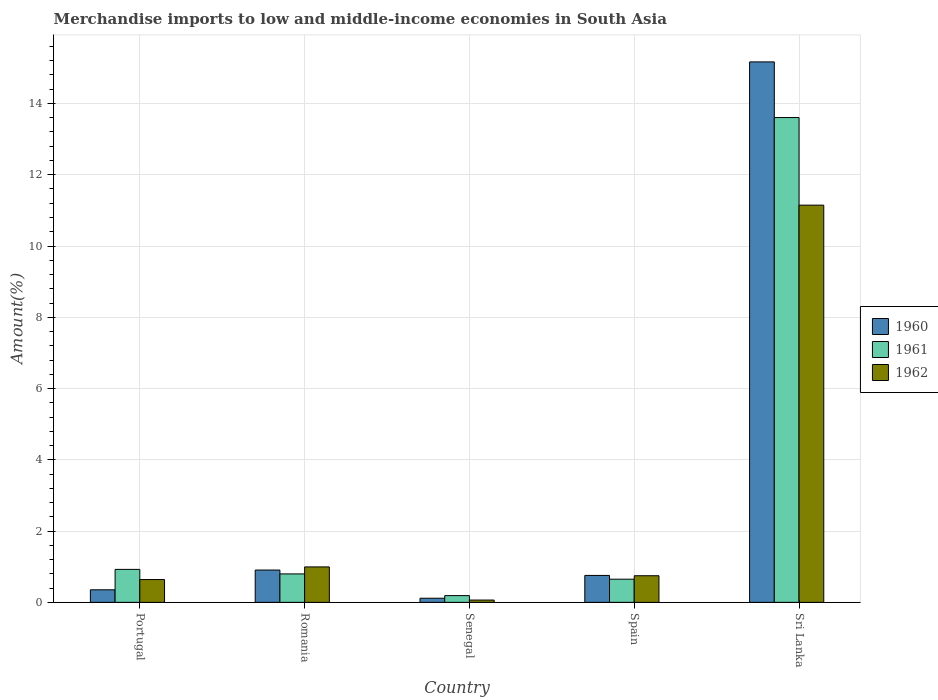How many different coloured bars are there?
Make the answer very short. 3. How many groups of bars are there?
Your response must be concise. 5. Are the number of bars on each tick of the X-axis equal?
Keep it short and to the point. Yes. How many bars are there on the 5th tick from the right?
Give a very brief answer. 3. What is the label of the 3rd group of bars from the left?
Provide a short and direct response. Senegal. What is the percentage of amount earned from merchandise imports in 1960 in Romania?
Offer a very short reply. 0.91. Across all countries, what is the maximum percentage of amount earned from merchandise imports in 1960?
Your answer should be very brief. 15.17. Across all countries, what is the minimum percentage of amount earned from merchandise imports in 1962?
Provide a succinct answer. 0.06. In which country was the percentage of amount earned from merchandise imports in 1961 maximum?
Offer a terse response. Sri Lanka. In which country was the percentage of amount earned from merchandise imports in 1962 minimum?
Ensure brevity in your answer.  Senegal. What is the total percentage of amount earned from merchandise imports in 1960 in the graph?
Your answer should be very brief. 17.3. What is the difference between the percentage of amount earned from merchandise imports in 1960 in Portugal and that in Senegal?
Provide a short and direct response. 0.24. What is the difference between the percentage of amount earned from merchandise imports in 1961 in Sri Lanka and the percentage of amount earned from merchandise imports in 1962 in Senegal?
Your answer should be compact. 13.54. What is the average percentage of amount earned from merchandise imports in 1961 per country?
Your answer should be very brief. 3.23. What is the difference between the percentage of amount earned from merchandise imports of/in 1961 and percentage of amount earned from merchandise imports of/in 1962 in Sri Lanka?
Offer a very short reply. 2.46. In how many countries, is the percentage of amount earned from merchandise imports in 1962 greater than 4.4 %?
Your response must be concise. 1. What is the ratio of the percentage of amount earned from merchandise imports in 1962 in Portugal to that in Sri Lanka?
Your response must be concise. 0.06. Is the percentage of amount earned from merchandise imports in 1961 in Romania less than that in Sri Lanka?
Offer a terse response. Yes. What is the difference between the highest and the second highest percentage of amount earned from merchandise imports in 1962?
Provide a short and direct response. 0.25. What is the difference between the highest and the lowest percentage of amount earned from merchandise imports in 1962?
Provide a succinct answer. 11.08. How many bars are there?
Offer a terse response. 15. Are all the bars in the graph horizontal?
Your answer should be compact. No. How many countries are there in the graph?
Provide a succinct answer. 5. What is the difference between two consecutive major ticks on the Y-axis?
Keep it short and to the point. 2. Where does the legend appear in the graph?
Provide a short and direct response. Center right. How are the legend labels stacked?
Provide a succinct answer. Vertical. What is the title of the graph?
Give a very brief answer. Merchandise imports to low and middle-income economies in South Asia. Does "2003" appear as one of the legend labels in the graph?
Your answer should be very brief. No. What is the label or title of the X-axis?
Offer a very short reply. Country. What is the label or title of the Y-axis?
Make the answer very short. Amount(%). What is the Amount(%) of 1960 in Portugal?
Your response must be concise. 0.35. What is the Amount(%) in 1961 in Portugal?
Offer a very short reply. 0.93. What is the Amount(%) of 1962 in Portugal?
Offer a terse response. 0.64. What is the Amount(%) in 1960 in Romania?
Offer a very short reply. 0.91. What is the Amount(%) in 1961 in Romania?
Provide a short and direct response. 0.8. What is the Amount(%) of 1962 in Romania?
Give a very brief answer. 0.99. What is the Amount(%) of 1960 in Senegal?
Offer a very short reply. 0.12. What is the Amount(%) in 1961 in Senegal?
Your answer should be compact. 0.19. What is the Amount(%) of 1962 in Senegal?
Your answer should be compact. 0.06. What is the Amount(%) of 1960 in Spain?
Your answer should be very brief. 0.76. What is the Amount(%) of 1961 in Spain?
Ensure brevity in your answer.  0.65. What is the Amount(%) of 1962 in Spain?
Provide a short and direct response. 0.75. What is the Amount(%) of 1960 in Sri Lanka?
Offer a very short reply. 15.17. What is the Amount(%) of 1961 in Sri Lanka?
Provide a short and direct response. 13.6. What is the Amount(%) in 1962 in Sri Lanka?
Provide a short and direct response. 11.15. Across all countries, what is the maximum Amount(%) in 1960?
Provide a succinct answer. 15.17. Across all countries, what is the maximum Amount(%) of 1961?
Make the answer very short. 13.6. Across all countries, what is the maximum Amount(%) of 1962?
Make the answer very short. 11.15. Across all countries, what is the minimum Amount(%) in 1960?
Offer a terse response. 0.12. Across all countries, what is the minimum Amount(%) of 1961?
Keep it short and to the point. 0.19. Across all countries, what is the minimum Amount(%) of 1962?
Your answer should be very brief. 0.06. What is the total Amount(%) in 1960 in the graph?
Your response must be concise. 17.3. What is the total Amount(%) in 1961 in the graph?
Give a very brief answer. 16.17. What is the total Amount(%) in 1962 in the graph?
Your answer should be very brief. 13.59. What is the difference between the Amount(%) in 1960 in Portugal and that in Romania?
Make the answer very short. -0.55. What is the difference between the Amount(%) of 1961 in Portugal and that in Romania?
Your answer should be very brief. 0.13. What is the difference between the Amount(%) of 1962 in Portugal and that in Romania?
Offer a very short reply. -0.35. What is the difference between the Amount(%) in 1960 in Portugal and that in Senegal?
Your response must be concise. 0.24. What is the difference between the Amount(%) in 1961 in Portugal and that in Senegal?
Give a very brief answer. 0.74. What is the difference between the Amount(%) of 1962 in Portugal and that in Senegal?
Give a very brief answer. 0.57. What is the difference between the Amount(%) in 1960 in Portugal and that in Spain?
Make the answer very short. -0.4. What is the difference between the Amount(%) in 1961 in Portugal and that in Spain?
Your answer should be compact. 0.28. What is the difference between the Amount(%) of 1962 in Portugal and that in Spain?
Your answer should be compact. -0.11. What is the difference between the Amount(%) in 1960 in Portugal and that in Sri Lanka?
Your response must be concise. -14.81. What is the difference between the Amount(%) in 1961 in Portugal and that in Sri Lanka?
Your answer should be compact. -12.68. What is the difference between the Amount(%) in 1962 in Portugal and that in Sri Lanka?
Your answer should be very brief. -10.51. What is the difference between the Amount(%) of 1960 in Romania and that in Senegal?
Offer a terse response. 0.79. What is the difference between the Amount(%) in 1961 in Romania and that in Senegal?
Keep it short and to the point. 0.61. What is the difference between the Amount(%) in 1962 in Romania and that in Senegal?
Provide a succinct answer. 0.93. What is the difference between the Amount(%) in 1960 in Romania and that in Spain?
Make the answer very short. 0.15. What is the difference between the Amount(%) of 1961 in Romania and that in Spain?
Your answer should be very brief. 0.15. What is the difference between the Amount(%) of 1962 in Romania and that in Spain?
Your response must be concise. 0.25. What is the difference between the Amount(%) in 1960 in Romania and that in Sri Lanka?
Offer a very short reply. -14.26. What is the difference between the Amount(%) of 1961 in Romania and that in Sri Lanka?
Provide a short and direct response. -12.81. What is the difference between the Amount(%) in 1962 in Romania and that in Sri Lanka?
Make the answer very short. -10.15. What is the difference between the Amount(%) of 1960 in Senegal and that in Spain?
Your response must be concise. -0.64. What is the difference between the Amount(%) of 1961 in Senegal and that in Spain?
Give a very brief answer. -0.46. What is the difference between the Amount(%) of 1962 in Senegal and that in Spain?
Provide a succinct answer. -0.68. What is the difference between the Amount(%) of 1960 in Senegal and that in Sri Lanka?
Keep it short and to the point. -15.05. What is the difference between the Amount(%) in 1961 in Senegal and that in Sri Lanka?
Your answer should be very brief. -13.42. What is the difference between the Amount(%) in 1962 in Senegal and that in Sri Lanka?
Give a very brief answer. -11.08. What is the difference between the Amount(%) of 1960 in Spain and that in Sri Lanka?
Provide a short and direct response. -14.41. What is the difference between the Amount(%) of 1961 in Spain and that in Sri Lanka?
Your answer should be compact. -12.95. What is the difference between the Amount(%) in 1962 in Spain and that in Sri Lanka?
Your answer should be compact. -10.4. What is the difference between the Amount(%) in 1960 in Portugal and the Amount(%) in 1961 in Romania?
Your answer should be compact. -0.45. What is the difference between the Amount(%) of 1960 in Portugal and the Amount(%) of 1962 in Romania?
Make the answer very short. -0.64. What is the difference between the Amount(%) of 1961 in Portugal and the Amount(%) of 1962 in Romania?
Offer a terse response. -0.07. What is the difference between the Amount(%) in 1960 in Portugal and the Amount(%) in 1961 in Senegal?
Provide a succinct answer. 0.16. What is the difference between the Amount(%) in 1960 in Portugal and the Amount(%) in 1962 in Senegal?
Your answer should be very brief. 0.29. What is the difference between the Amount(%) of 1961 in Portugal and the Amount(%) of 1962 in Senegal?
Offer a terse response. 0.86. What is the difference between the Amount(%) in 1960 in Portugal and the Amount(%) in 1961 in Spain?
Your response must be concise. -0.3. What is the difference between the Amount(%) of 1960 in Portugal and the Amount(%) of 1962 in Spain?
Your answer should be very brief. -0.39. What is the difference between the Amount(%) of 1961 in Portugal and the Amount(%) of 1962 in Spain?
Offer a terse response. 0.18. What is the difference between the Amount(%) in 1960 in Portugal and the Amount(%) in 1961 in Sri Lanka?
Your response must be concise. -13.25. What is the difference between the Amount(%) of 1960 in Portugal and the Amount(%) of 1962 in Sri Lanka?
Your response must be concise. -10.79. What is the difference between the Amount(%) of 1961 in Portugal and the Amount(%) of 1962 in Sri Lanka?
Your answer should be very brief. -10.22. What is the difference between the Amount(%) in 1960 in Romania and the Amount(%) in 1961 in Senegal?
Your response must be concise. 0.72. What is the difference between the Amount(%) of 1960 in Romania and the Amount(%) of 1962 in Senegal?
Give a very brief answer. 0.84. What is the difference between the Amount(%) of 1961 in Romania and the Amount(%) of 1962 in Senegal?
Provide a succinct answer. 0.73. What is the difference between the Amount(%) in 1960 in Romania and the Amount(%) in 1961 in Spain?
Provide a short and direct response. 0.26. What is the difference between the Amount(%) of 1960 in Romania and the Amount(%) of 1962 in Spain?
Your answer should be compact. 0.16. What is the difference between the Amount(%) in 1961 in Romania and the Amount(%) in 1962 in Spain?
Provide a short and direct response. 0.05. What is the difference between the Amount(%) in 1960 in Romania and the Amount(%) in 1961 in Sri Lanka?
Your response must be concise. -12.7. What is the difference between the Amount(%) in 1960 in Romania and the Amount(%) in 1962 in Sri Lanka?
Offer a terse response. -10.24. What is the difference between the Amount(%) in 1961 in Romania and the Amount(%) in 1962 in Sri Lanka?
Keep it short and to the point. -10.35. What is the difference between the Amount(%) in 1960 in Senegal and the Amount(%) in 1961 in Spain?
Keep it short and to the point. -0.53. What is the difference between the Amount(%) in 1960 in Senegal and the Amount(%) in 1962 in Spain?
Give a very brief answer. -0.63. What is the difference between the Amount(%) of 1961 in Senegal and the Amount(%) of 1962 in Spain?
Your response must be concise. -0.56. What is the difference between the Amount(%) of 1960 in Senegal and the Amount(%) of 1961 in Sri Lanka?
Offer a terse response. -13.49. What is the difference between the Amount(%) of 1960 in Senegal and the Amount(%) of 1962 in Sri Lanka?
Your answer should be very brief. -11.03. What is the difference between the Amount(%) in 1961 in Senegal and the Amount(%) in 1962 in Sri Lanka?
Provide a short and direct response. -10.96. What is the difference between the Amount(%) in 1960 in Spain and the Amount(%) in 1961 in Sri Lanka?
Your answer should be very brief. -12.85. What is the difference between the Amount(%) in 1960 in Spain and the Amount(%) in 1962 in Sri Lanka?
Provide a succinct answer. -10.39. What is the difference between the Amount(%) in 1961 in Spain and the Amount(%) in 1962 in Sri Lanka?
Offer a terse response. -10.5. What is the average Amount(%) of 1960 per country?
Your response must be concise. 3.46. What is the average Amount(%) of 1961 per country?
Provide a succinct answer. 3.23. What is the average Amount(%) in 1962 per country?
Offer a very short reply. 2.72. What is the difference between the Amount(%) in 1960 and Amount(%) in 1961 in Portugal?
Make the answer very short. -0.57. What is the difference between the Amount(%) of 1960 and Amount(%) of 1962 in Portugal?
Make the answer very short. -0.29. What is the difference between the Amount(%) in 1961 and Amount(%) in 1962 in Portugal?
Your answer should be very brief. 0.29. What is the difference between the Amount(%) of 1960 and Amount(%) of 1961 in Romania?
Offer a very short reply. 0.11. What is the difference between the Amount(%) in 1960 and Amount(%) in 1962 in Romania?
Provide a short and direct response. -0.09. What is the difference between the Amount(%) in 1961 and Amount(%) in 1962 in Romania?
Offer a very short reply. -0.2. What is the difference between the Amount(%) of 1960 and Amount(%) of 1961 in Senegal?
Ensure brevity in your answer.  -0.07. What is the difference between the Amount(%) of 1960 and Amount(%) of 1962 in Senegal?
Your response must be concise. 0.05. What is the difference between the Amount(%) in 1961 and Amount(%) in 1962 in Senegal?
Keep it short and to the point. 0.12. What is the difference between the Amount(%) in 1960 and Amount(%) in 1961 in Spain?
Your answer should be very brief. 0.11. What is the difference between the Amount(%) of 1960 and Amount(%) of 1962 in Spain?
Your answer should be compact. 0.01. What is the difference between the Amount(%) in 1961 and Amount(%) in 1962 in Spain?
Provide a succinct answer. -0.1. What is the difference between the Amount(%) of 1960 and Amount(%) of 1961 in Sri Lanka?
Keep it short and to the point. 1.56. What is the difference between the Amount(%) of 1960 and Amount(%) of 1962 in Sri Lanka?
Provide a succinct answer. 4.02. What is the difference between the Amount(%) in 1961 and Amount(%) in 1962 in Sri Lanka?
Offer a very short reply. 2.46. What is the ratio of the Amount(%) of 1960 in Portugal to that in Romania?
Provide a short and direct response. 0.39. What is the ratio of the Amount(%) of 1961 in Portugal to that in Romania?
Your answer should be very brief. 1.16. What is the ratio of the Amount(%) in 1962 in Portugal to that in Romania?
Your answer should be compact. 0.64. What is the ratio of the Amount(%) in 1960 in Portugal to that in Senegal?
Your response must be concise. 3.04. What is the ratio of the Amount(%) of 1961 in Portugal to that in Senegal?
Ensure brevity in your answer.  4.89. What is the ratio of the Amount(%) in 1962 in Portugal to that in Senegal?
Provide a short and direct response. 9.88. What is the ratio of the Amount(%) in 1960 in Portugal to that in Spain?
Offer a terse response. 0.47. What is the ratio of the Amount(%) of 1961 in Portugal to that in Spain?
Offer a terse response. 1.42. What is the ratio of the Amount(%) in 1962 in Portugal to that in Spain?
Offer a very short reply. 0.86. What is the ratio of the Amount(%) in 1960 in Portugal to that in Sri Lanka?
Your answer should be compact. 0.02. What is the ratio of the Amount(%) in 1961 in Portugal to that in Sri Lanka?
Keep it short and to the point. 0.07. What is the ratio of the Amount(%) of 1962 in Portugal to that in Sri Lanka?
Your response must be concise. 0.06. What is the ratio of the Amount(%) of 1960 in Romania to that in Senegal?
Your answer should be compact. 7.82. What is the ratio of the Amount(%) of 1961 in Romania to that in Senegal?
Make the answer very short. 4.22. What is the ratio of the Amount(%) in 1962 in Romania to that in Senegal?
Keep it short and to the point. 15.36. What is the ratio of the Amount(%) in 1960 in Romania to that in Spain?
Provide a short and direct response. 1.2. What is the ratio of the Amount(%) of 1961 in Romania to that in Spain?
Your answer should be compact. 1.23. What is the ratio of the Amount(%) in 1962 in Romania to that in Spain?
Your answer should be very brief. 1.33. What is the ratio of the Amount(%) of 1960 in Romania to that in Sri Lanka?
Make the answer very short. 0.06. What is the ratio of the Amount(%) of 1961 in Romania to that in Sri Lanka?
Your response must be concise. 0.06. What is the ratio of the Amount(%) of 1962 in Romania to that in Sri Lanka?
Provide a short and direct response. 0.09. What is the ratio of the Amount(%) of 1960 in Senegal to that in Spain?
Give a very brief answer. 0.15. What is the ratio of the Amount(%) in 1961 in Senegal to that in Spain?
Your answer should be compact. 0.29. What is the ratio of the Amount(%) in 1962 in Senegal to that in Spain?
Keep it short and to the point. 0.09. What is the ratio of the Amount(%) of 1960 in Senegal to that in Sri Lanka?
Your answer should be very brief. 0.01. What is the ratio of the Amount(%) of 1961 in Senegal to that in Sri Lanka?
Provide a succinct answer. 0.01. What is the ratio of the Amount(%) in 1962 in Senegal to that in Sri Lanka?
Give a very brief answer. 0.01. What is the ratio of the Amount(%) in 1960 in Spain to that in Sri Lanka?
Offer a terse response. 0.05. What is the ratio of the Amount(%) of 1961 in Spain to that in Sri Lanka?
Keep it short and to the point. 0.05. What is the ratio of the Amount(%) in 1962 in Spain to that in Sri Lanka?
Make the answer very short. 0.07. What is the difference between the highest and the second highest Amount(%) in 1960?
Give a very brief answer. 14.26. What is the difference between the highest and the second highest Amount(%) in 1961?
Give a very brief answer. 12.68. What is the difference between the highest and the second highest Amount(%) of 1962?
Your answer should be compact. 10.15. What is the difference between the highest and the lowest Amount(%) of 1960?
Your answer should be compact. 15.05. What is the difference between the highest and the lowest Amount(%) in 1961?
Provide a short and direct response. 13.42. What is the difference between the highest and the lowest Amount(%) in 1962?
Keep it short and to the point. 11.08. 